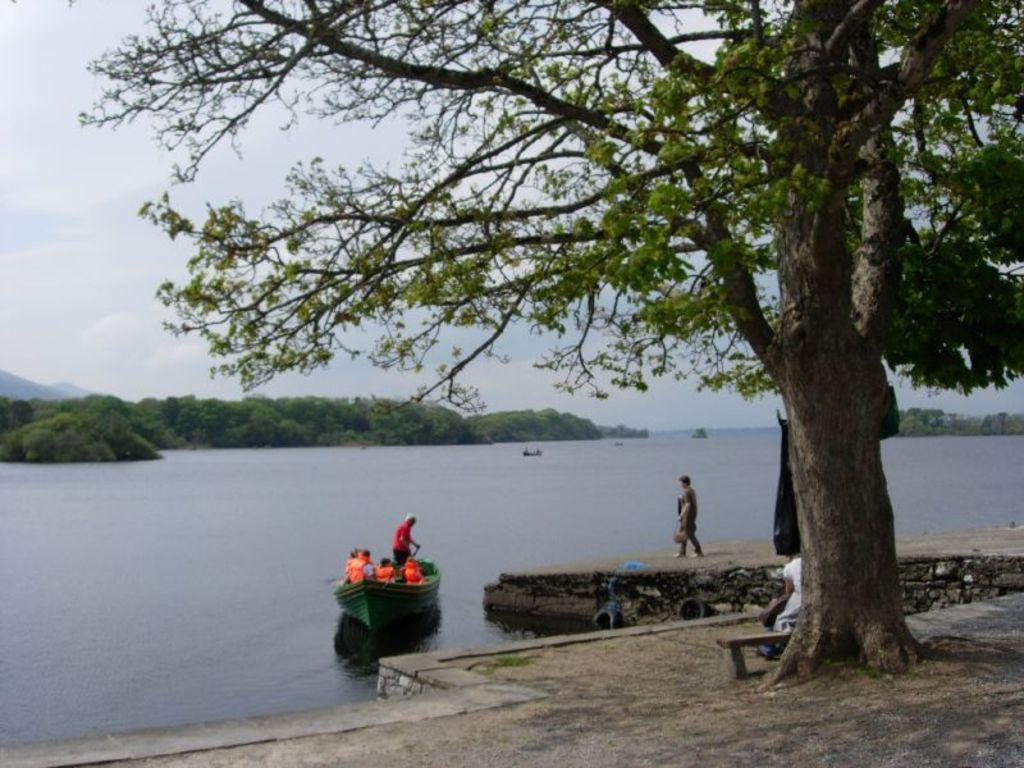What are the people in the image doing? The people in the image are sitting on a boat. What can be seen in the background of the image? There are trees visible in the image. What body of water is the boat on? There is a river in the image. What is visible above the trees and river in the image? The sky is visible in the image. What type of substance is being used to ring the bell in the image? There is no bell present in the image. What kind of plant is growing near the river in the image? The provided facts do not mention any specific plants near the river, only trees in the background. 